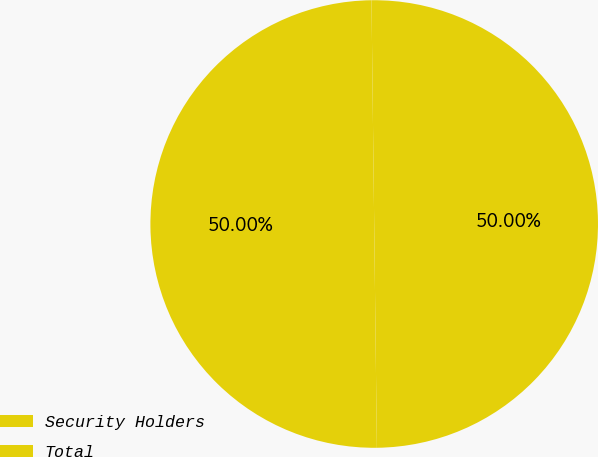<chart> <loc_0><loc_0><loc_500><loc_500><pie_chart><fcel>Security Holders<fcel>Total<nl><fcel>50.0%<fcel>50.0%<nl></chart> 